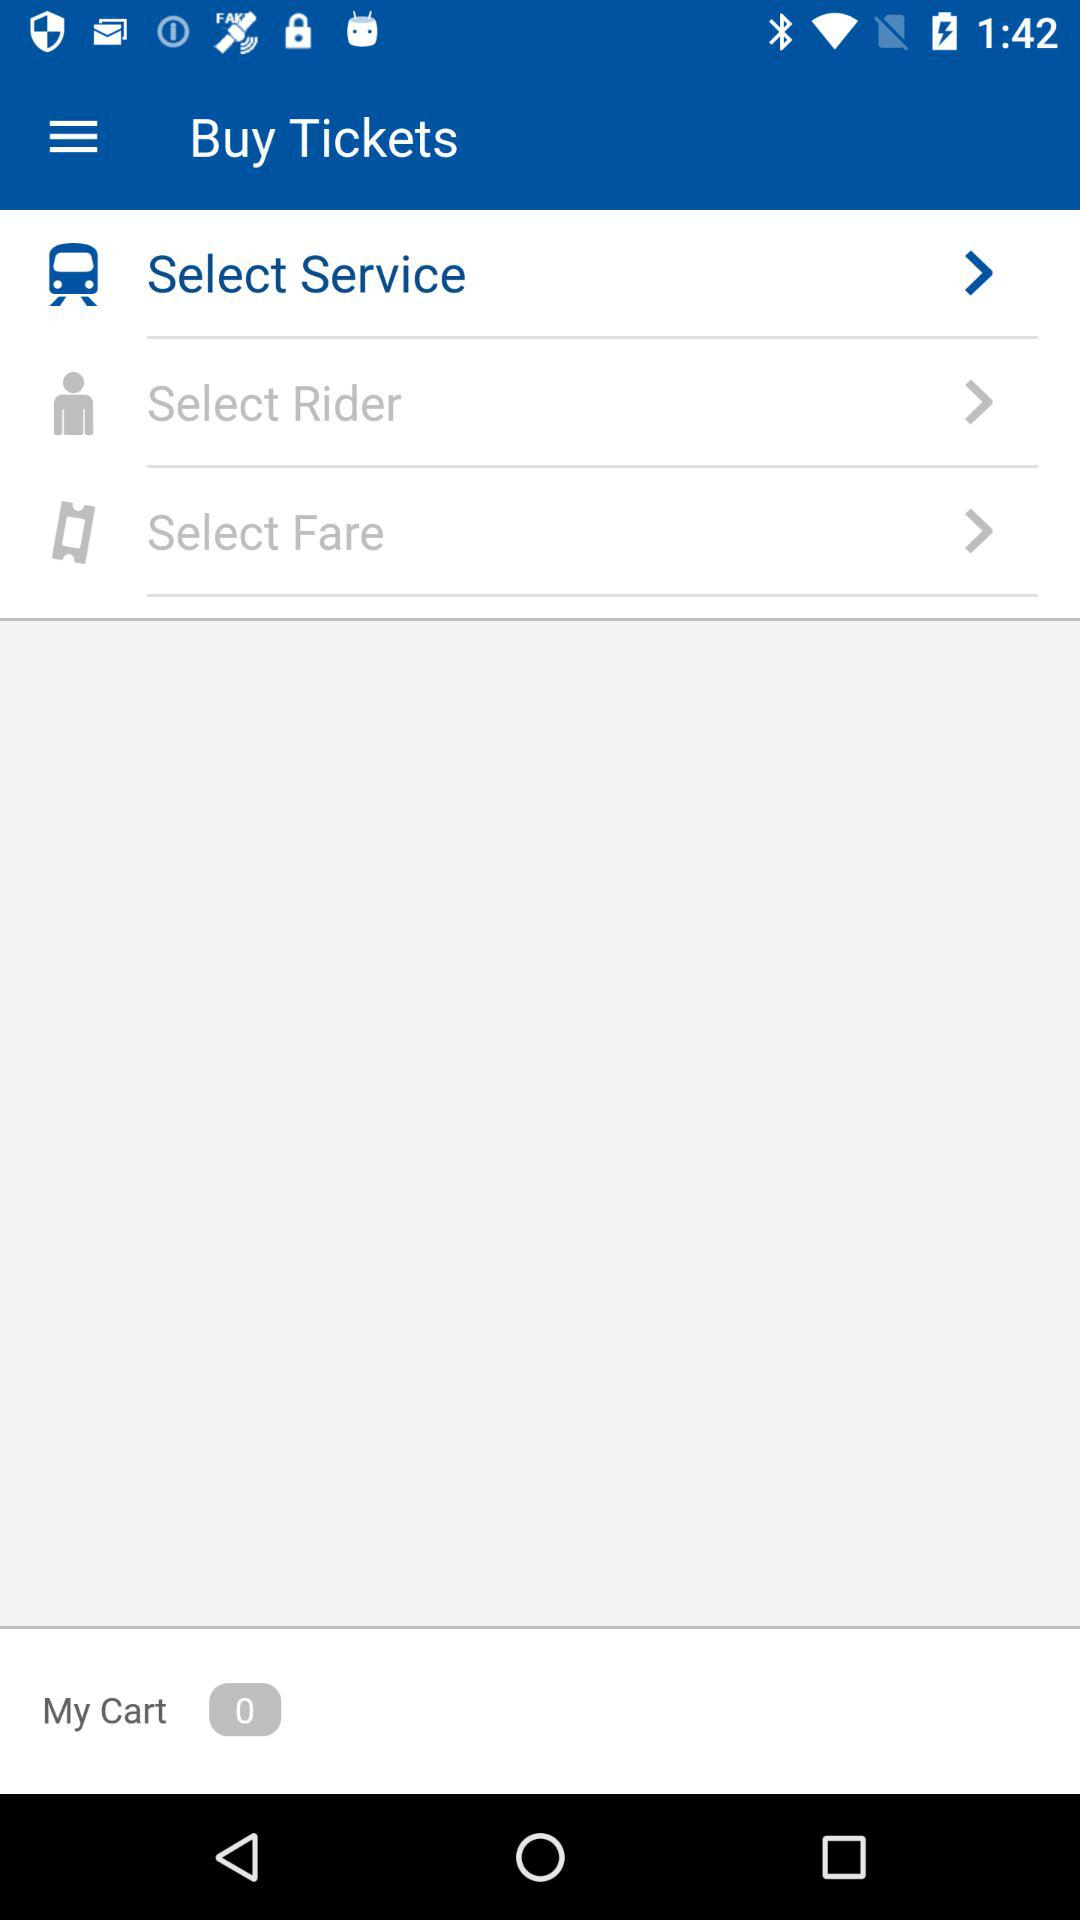How many items are in the cart? There are 0 items in the cart. 